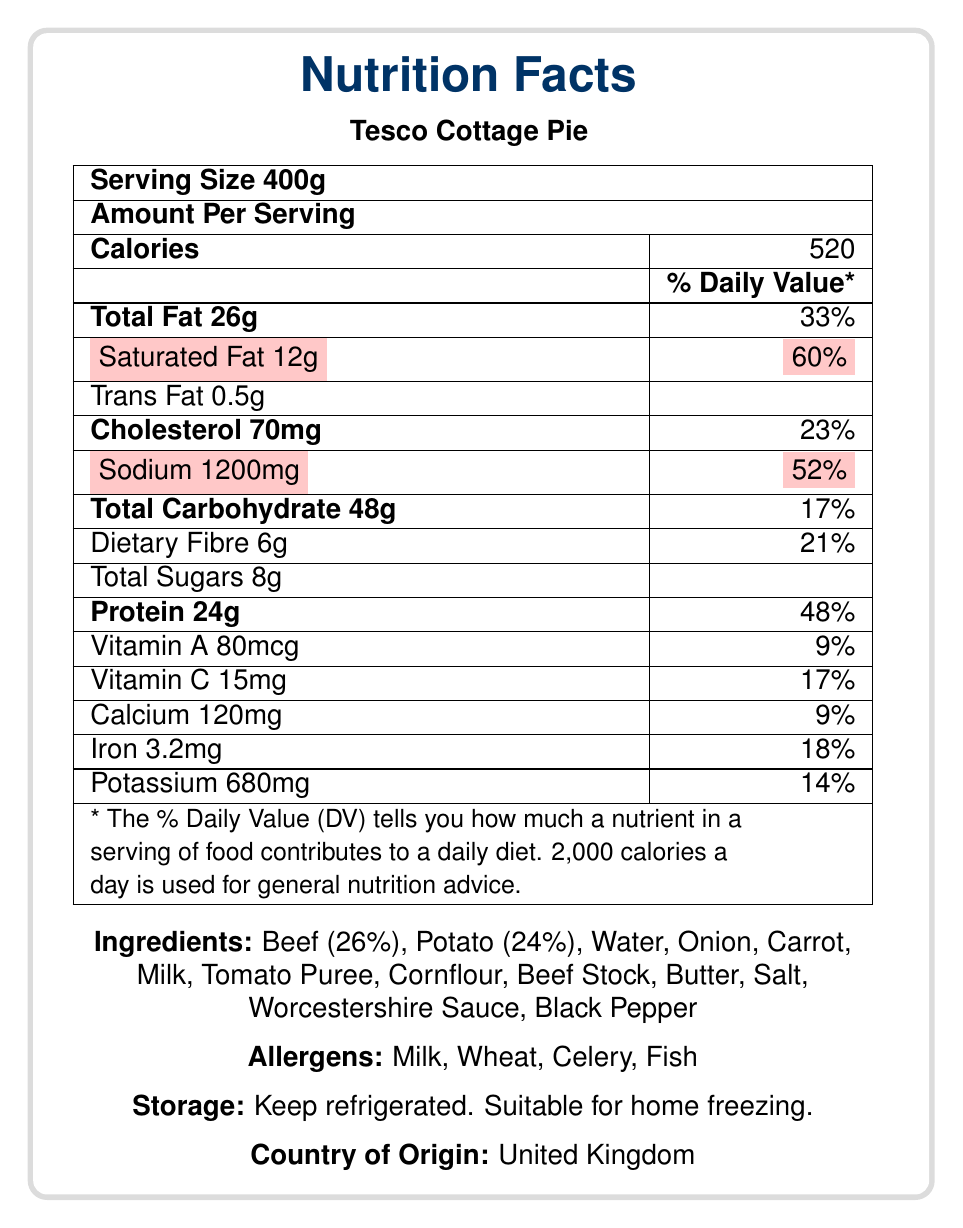what is the serving size for Tesco Cottage Pie? The document specifies that the serving size is 400g.
Answer: 400g how many calories are in one serving of Tesco Cottage Pie? According to the document, the number of calories in one serving is 520.
Answer: 520 calories what is the percentage daily value of saturated fat in one serving? The document shows that one serving of Tesco Cottage Pie has 12g of saturated fat, which is 60% of the daily value.
Answer: 60% how much sodium is in one serving of Tesco Cottage Pie? The amount of sodium in one serving is listed as 1200mg in the document.
Answer: 1200mg what are the allergens mentioned for Tesco Cottage Pie? The allergens listed in the document are Milk, Wheat, Celery, and Fish.
Answer: Milk, Wheat, Celery, Fish which of the following nutrients has the highest percentage daily value in one serving? A. Protein B. Sodium C. Total Carbohydrate D. Cholesterol Sodium has a daily value of 52% which is higher than Protein (48%), Total Carbohydrate (17%), and Cholesterol (23%).
Answer: B. Sodium what is the country of origin for Tesco Cottage Pie? A. United States B. Canada C. United Kingdom D. Australia The document specifies that the country of origin is the United Kingdom.
Answer: C. United Kingdom does the Tesco Cottage Pie contain fish as an allergen? The document lists fish as one of the allergens.
Answer: Yes provide a summary of the nutritional information and other details found in the document. This summary covers the main nutritional details, ingredients, allergens, cooking instructions, and additional information like storage and packaging from the document.
Answer: The Tesco Cottage Pie is a 400g ready meal containing 520 calories per serving. Key nutritional values include 26g of total fat (33% DV), 12g of saturated fat (60% DV), 1200mg of sodium (52% DV), 48g of carbohydrates (17% DV), 24g of protein (48% DV), along with smaller amounts of various vitamins and minerals. The ingredients list includes beef, potato, and various other components, and the product contains allergens such as milk, wheat, celery, and fish. It should be stored refrigerated or frozen, and it is made in the United Kingdom. what is the daily value percentage of dietary fibre in one serving? The document states that one serving contains 6g of dietary fibre, which is 21% of the daily value.
Answer: 21% how many grams of total sugars does one serving contain? The document lists that there are 8g of total sugars in one serving.
Answer: 8g does Tesco Cottage Pie contain any trans fat? The document specifies that the pie contains 0.5g of trans fat per serving.
Answer: Yes, 0.5g how long should you cook Tesco Cottage Pie in a pre-heated oven? According to the cooking instructions, it should be cooked for 30-35 minutes in a pre-heated oven.
Answer: 30-35 minutes what materials is the packaging made from? The additional information specifies that the packaging includes a plastic tray, which is recyclable, and a film lid, which is not recyclable.
Answer: Plastic tray with film lid. Tray recyclable, film not recyclable. how long can you store the Tesco Cottage Pie in the freezer? The storage instructions specify that it can be frozen on the day of purchase and used within one month.
Answer: One month from the day of purchase what percentage of the Tesco Cottage Pie is made up of beef? The ingredients list specifies that Beef makes up 26% of the product.
Answer: 26% what is the level of saturated fat according to the traffic light labels? The document's traffic light labels indicate that the level of saturated fat is categorized as red, signaling a high amount.
Answer: Red what percentage of the daily value for calcium is provided by one serving? The document states that one serving contains 120mg of calcium, which is 9% of the daily value.
Answer: 9% is the Tesco Cottage Pie gluten-free? The document does not provide information on whether the Tesco Cottage Pie is gluten-free.
Answer: Cannot be determined how many servings are in one container of Tesco Cottage Pie? The document specifies that there is 1 serving per container.
Answer: 1 